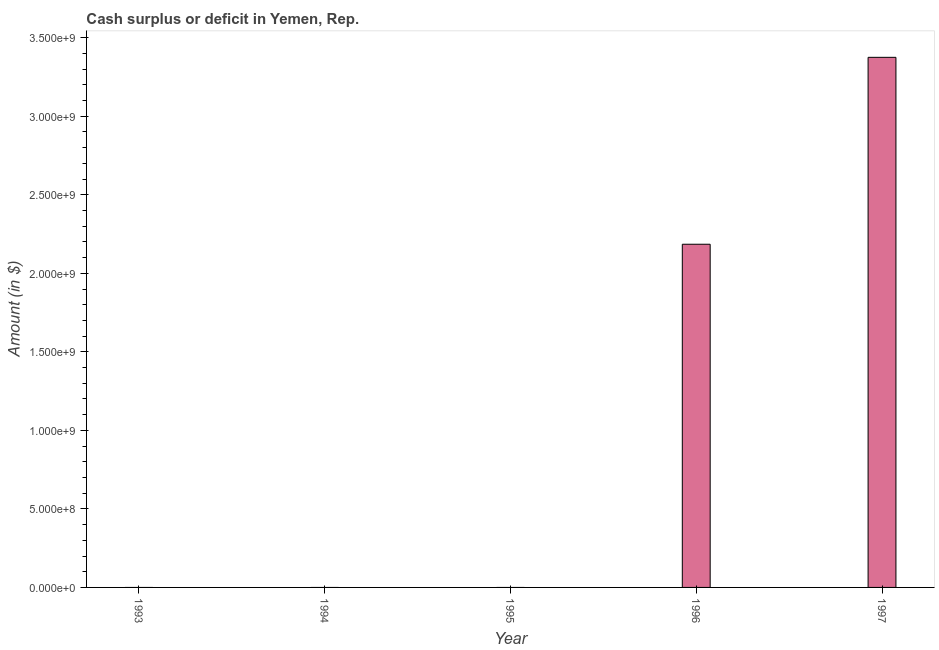What is the title of the graph?
Keep it short and to the point. Cash surplus or deficit in Yemen, Rep. What is the label or title of the X-axis?
Make the answer very short. Year. What is the label or title of the Y-axis?
Give a very brief answer. Amount (in $). Across all years, what is the maximum cash surplus or deficit?
Your answer should be compact. 3.38e+09. In which year was the cash surplus or deficit maximum?
Give a very brief answer. 1997. What is the sum of the cash surplus or deficit?
Provide a succinct answer. 5.56e+09. What is the difference between the cash surplus or deficit in 1996 and 1997?
Provide a succinct answer. -1.19e+09. What is the average cash surplus or deficit per year?
Keep it short and to the point. 1.11e+09. Is the sum of the cash surplus or deficit in 1996 and 1997 greater than the maximum cash surplus or deficit across all years?
Give a very brief answer. Yes. What is the difference between the highest and the lowest cash surplus or deficit?
Your answer should be compact. 3.38e+09. In how many years, is the cash surplus or deficit greater than the average cash surplus or deficit taken over all years?
Offer a terse response. 2. How many years are there in the graph?
Your answer should be compact. 5. What is the difference between two consecutive major ticks on the Y-axis?
Provide a short and direct response. 5.00e+08. What is the Amount (in $) of 1994?
Ensure brevity in your answer.  0. What is the Amount (in $) in 1995?
Offer a terse response. 0. What is the Amount (in $) of 1996?
Give a very brief answer. 2.18e+09. What is the Amount (in $) in 1997?
Your answer should be very brief. 3.38e+09. What is the difference between the Amount (in $) in 1996 and 1997?
Your answer should be compact. -1.19e+09. What is the ratio of the Amount (in $) in 1996 to that in 1997?
Give a very brief answer. 0.65. 